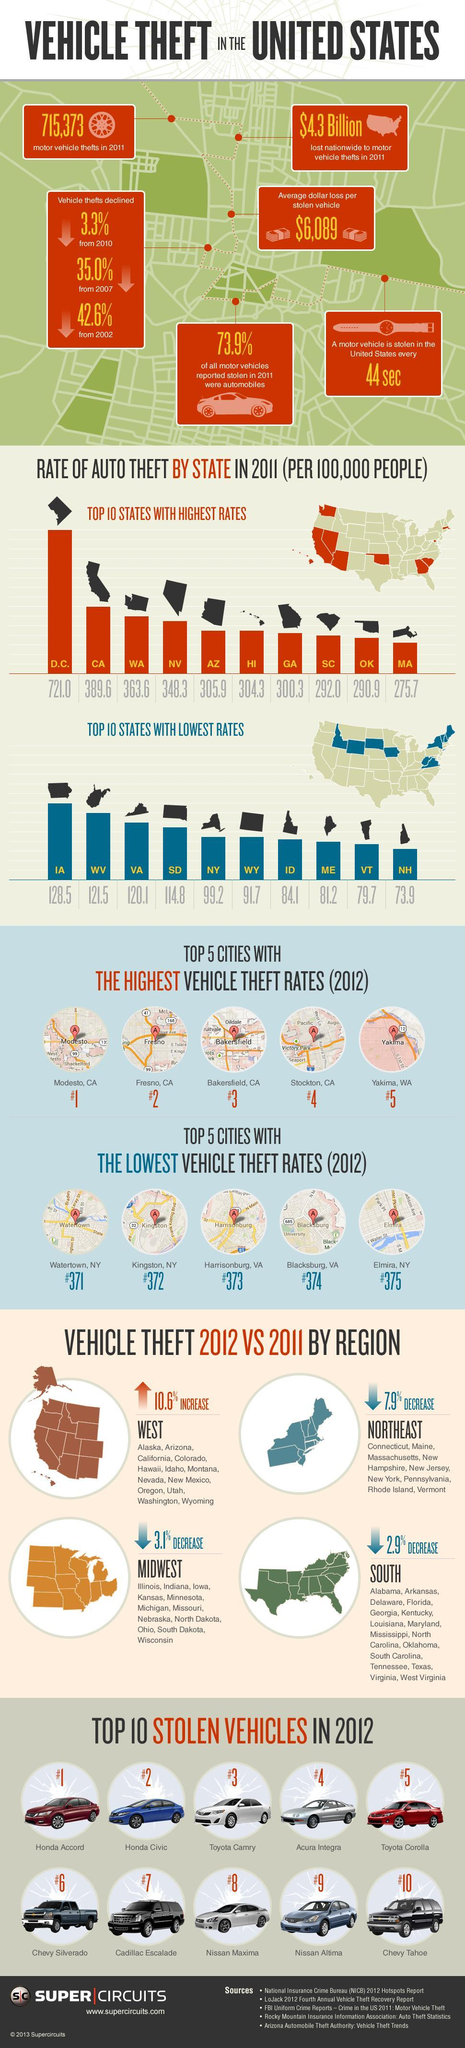Which state ranks 2 in the rate of theft in 2011?
Answer the question with a short phrase. CA Which was the top fourth vehicle to be stolen? Acura Integra Which region showed the most decrease in vehicle theft 2012 vs 2011? NORTHEAST Which city ranks 4th in vehicle theft rates as of 2012? Stockton, CA 